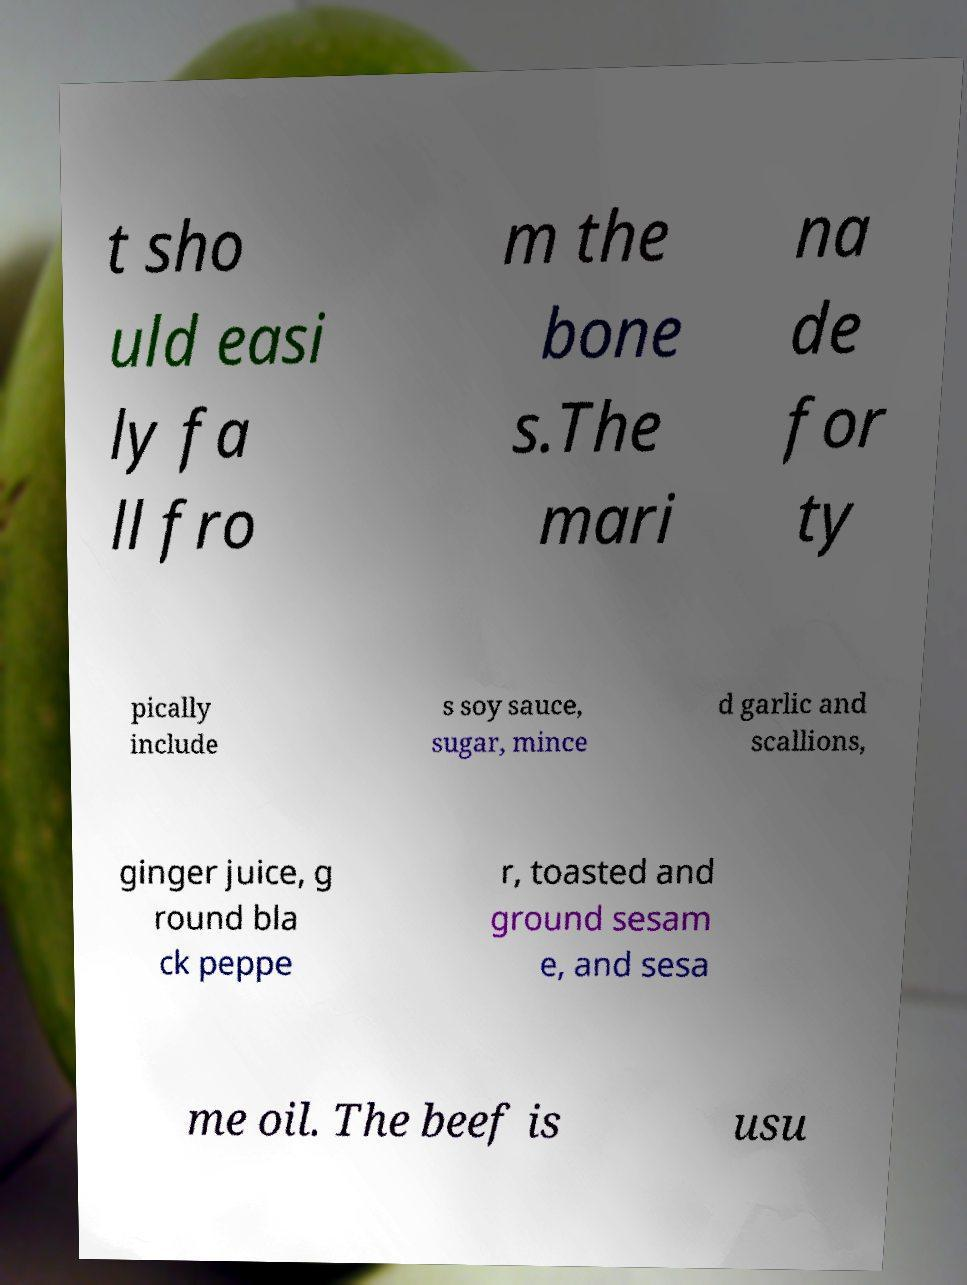For documentation purposes, I need the text within this image transcribed. Could you provide that? t sho uld easi ly fa ll fro m the bone s.The mari na de for ty pically include s soy sauce, sugar, mince d garlic and scallions, ginger juice, g round bla ck peppe r, toasted and ground sesam e, and sesa me oil. The beef is usu 